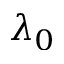<formula> <loc_0><loc_0><loc_500><loc_500>\lambda _ { 0 }</formula> 